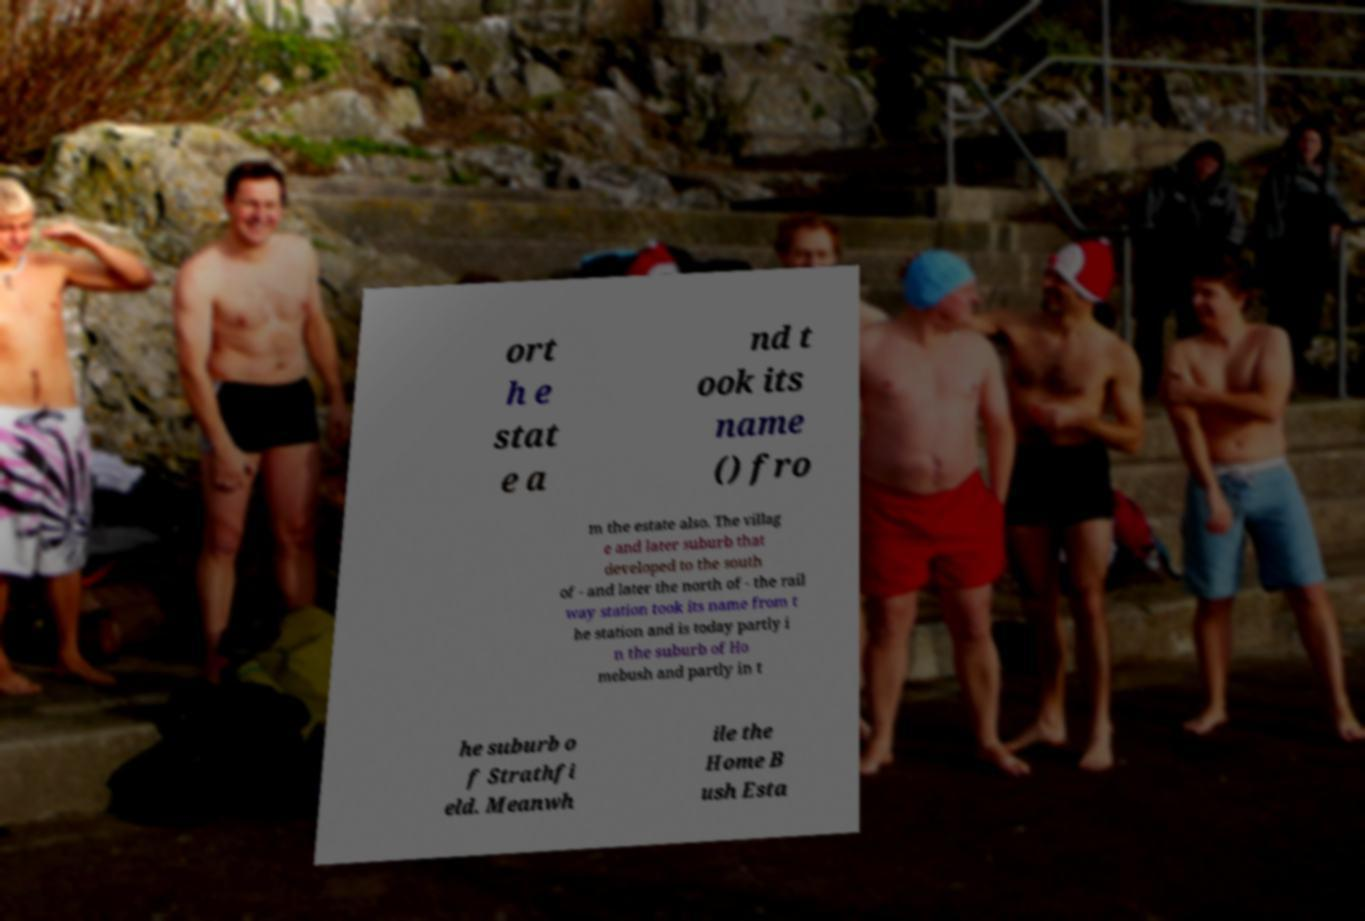Could you assist in decoding the text presented in this image and type it out clearly? ort h e stat e a nd t ook its name () fro m the estate also. The villag e and later suburb that developed to the south of - and later the north of - the rail way station took its name from t he station and is today partly i n the suburb of Ho mebush and partly in t he suburb o f Strathfi eld. Meanwh ile the Home B ush Esta 